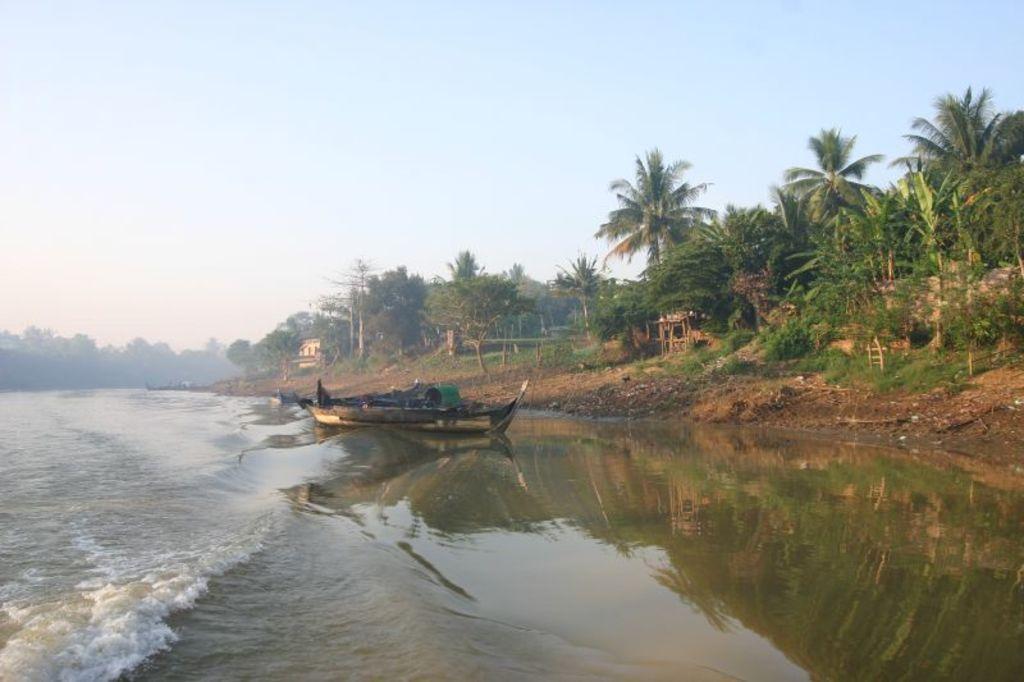Describe this image in one or two sentences. There are boats on the water of a river. In the background, there are trees, plants and grass on the ground and there are clouds in the sky. 